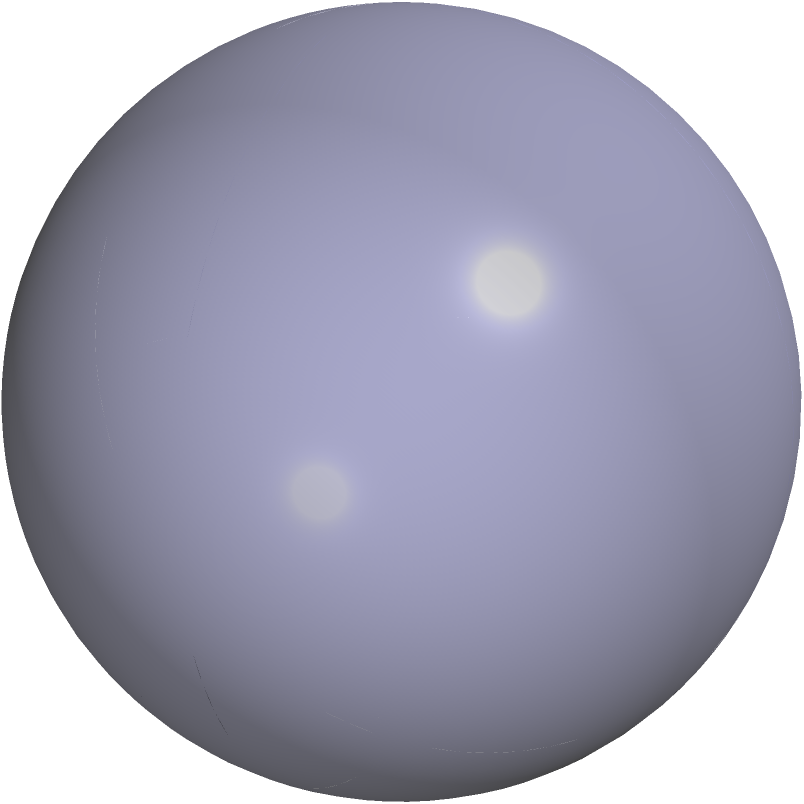In your latest fantasy novel, you've created a magical realm where the laws of geometry are warped. On a spherical surface within this realm, you've drawn a triangle ABC as shown in the figure. If the sum of the interior angles of this triangle is 270°, what is the ratio of the surface area of the triangle to the total surface area of the sphere? Express your answer as a fraction. To solve this problem, we'll use the properties of spherical geometry and the concept of spherical excess. Let's break it down step-by-step:

1) In spherical geometry, the sum of the interior angles of a triangle is always greater than 180°. The difference between this sum and 180° is called the spherical excess (E).

2) Given: The sum of the interior angles is 270°
   Spherical excess (E) = 270° - 180° = 90° = $\frac{\pi}{2}$ radians

3) There's a fundamental relationship in spherical geometry between the spherical excess and the area of a triangle on a sphere:

   Area of spherical triangle = $R^2 \cdot E$

   Where R is the radius of the sphere.

4) The total surface area of a sphere is given by $4\pi R^2$.

5) The ratio we're looking for is:
   $\frac{\text{Area of triangle}}{\text{Surface area of sphere}} = \frac{R^2 \cdot E}{4\pi R^2}$

6) Substituting E = $\frac{\pi}{2}$:
   $\frac{R^2 \cdot \frac{\pi}{2}}{4\pi R^2} = \frac{1}{8}$

Therefore, the ratio of the area of the triangle to the surface area of the sphere is 1:8 or $\frac{1}{8}$.
Answer: $\frac{1}{8}$ 